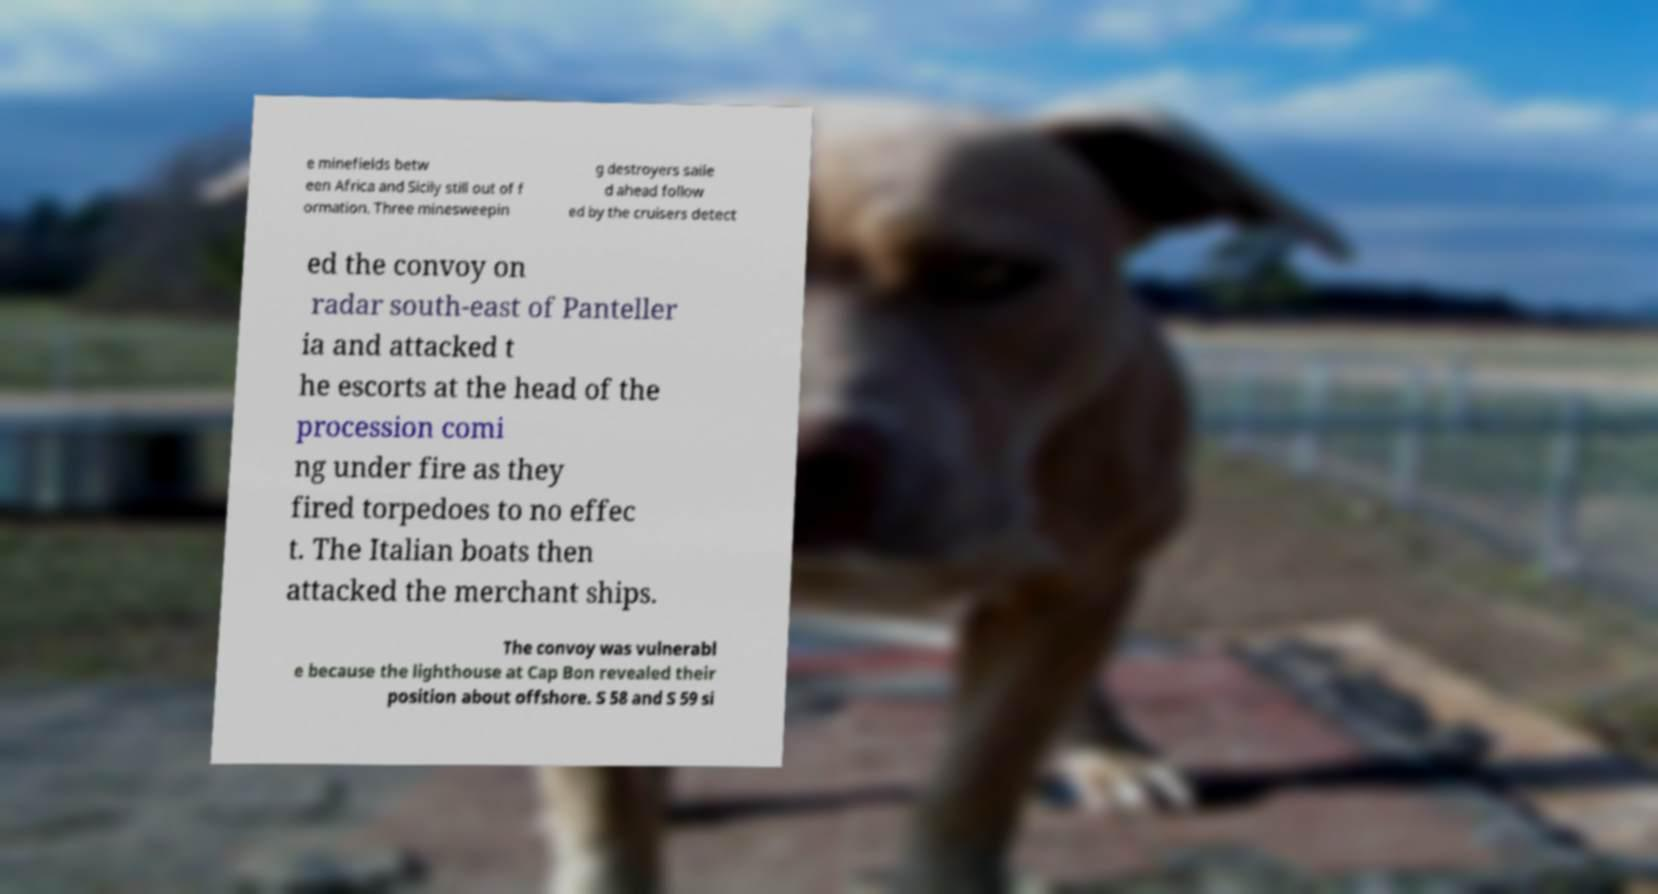For documentation purposes, I need the text within this image transcribed. Could you provide that? e minefields betw een Africa and Sicily still out of f ormation. Three minesweepin g destroyers saile d ahead follow ed by the cruisers detect ed the convoy on radar south-east of Panteller ia and attacked t he escorts at the head of the procession comi ng under fire as they fired torpedoes to no effec t. The Italian boats then attacked the merchant ships. The convoy was vulnerabl e because the lighthouse at Cap Bon revealed their position about offshore. S 58 and S 59 si 